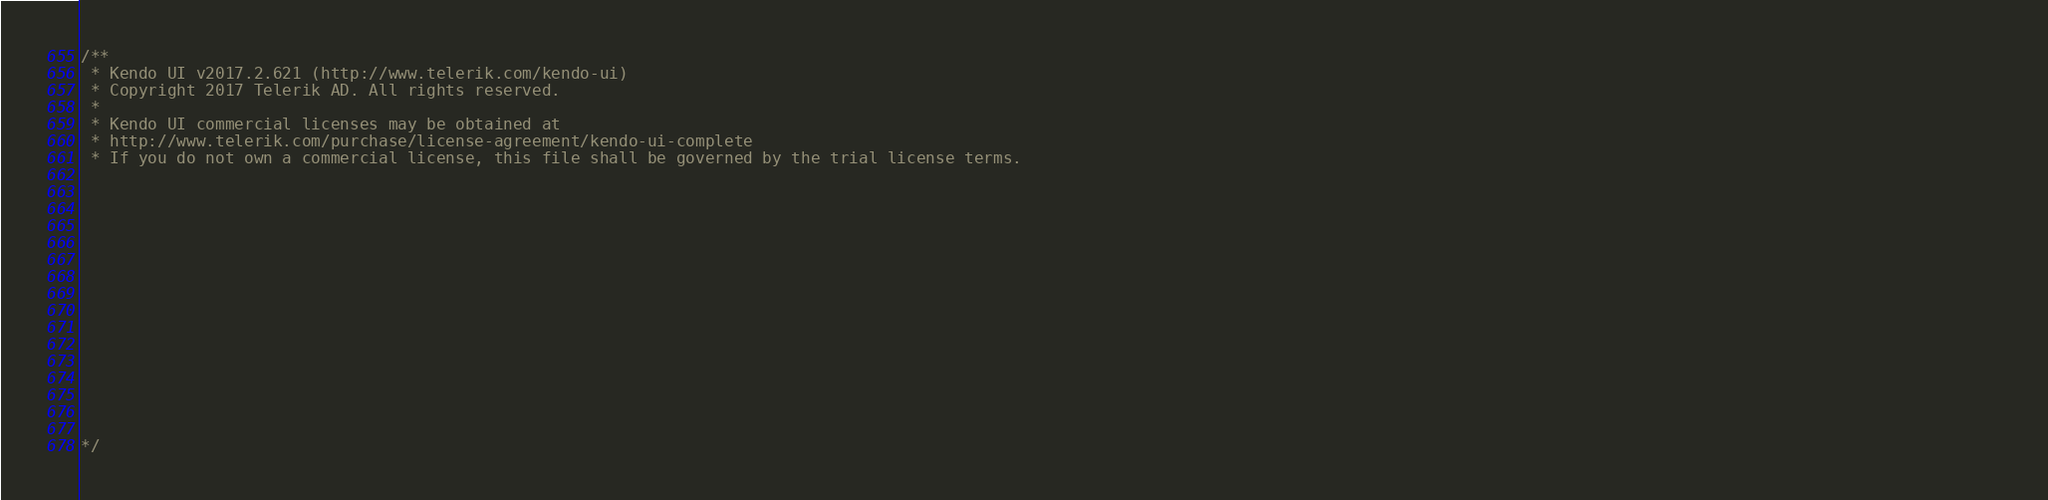Convert code to text. <code><loc_0><loc_0><loc_500><loc_500><_JavaScript_>/** 
 * Kendo UI v2017.2.621 (http://www.telerik.com/kendo-ui)                                                                                                                                               
 * Copyright 2017 Telerik AD. All rights reserved.                                                                                                                                                      
 *                                                                                                                                                                                                      
 * Kendo UI commercial licenses may be obtained at                                                                                                                                                      
 * http://www.telerik.com/purchase/license-agreement/kendo-ui-complete                                                                                                                                  
 * If you do not own a commercial license, this file shall be governed by the trial license terms.                                                                                                      
                                                                                                                                                                                                       
                                                                                                                                                                                                       
                                                                                                                                                                                                       
                                                                                                                                                                                                       
                                                                                                                                                                                                       
                                                                                                                                                                                                       
                                                                                                                                                                                                       
                                                                                                                                                                                                       
                                                                                                                                                                                                       
                                                                                                                                                                                                       
                                                                                                                                                                                                       
                                                                                                                                                                                                       
                                                                                                                                                                                                       
                                                                                                                                                                                                       
                                                                                                                                                                                                       

*/</code> 